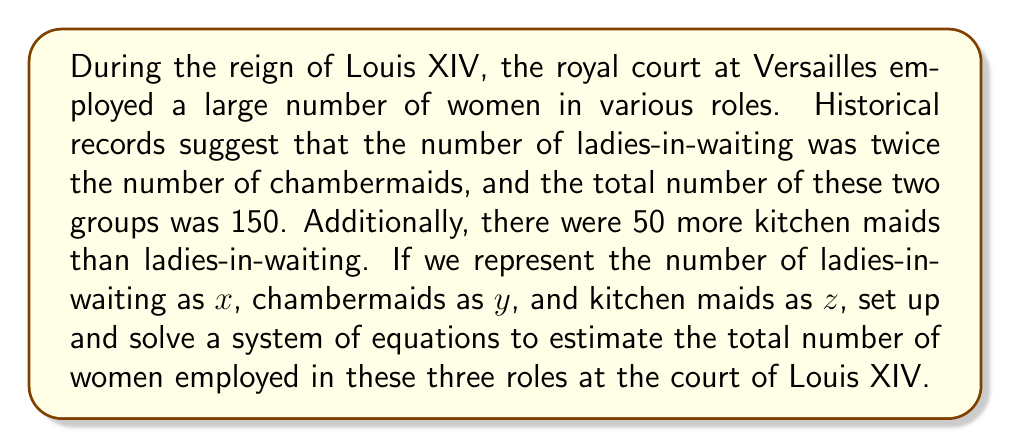Provide a solution to this math problem. Let's approach this step-by-step:

1) First, let's define our variables:
   $x$ = number of ladies-in-waiting
   $y$ = number of chambermaids
   $z$ = number of kitchen maids

2) Now, let's translate the given information into equations:
   - The number of ladies-in-waiting is twice the number of chambermaids:
     $$x = 2y$$
   - The total number of ladies-in-waiting and chambermaids is 150:
     $$x + y = 150$$
   - There are 50 more kitchen maids than ladies-in-waiting:
     $$z = x + 50$$

3) We can solve this system by substitution. Let's start with the first equation:
   $$x = 2y$$

4) Substitute this into the second equation:
   $$2y + y = 150$$
   $$3y = 150$$
   $$y = 50$$

5) Now we can find $x$:
   $$x = 2y = 2(50) = 100$$

6) And finally, we can find $z$:
   $$z = x + 50 = 100 + 50 = 150$$

7) To get the total number of women in these three roles, we add:
   $$\text{Total} = x + y + z = 100 + 50 + 150 = 300$$
Answer: 300 women 